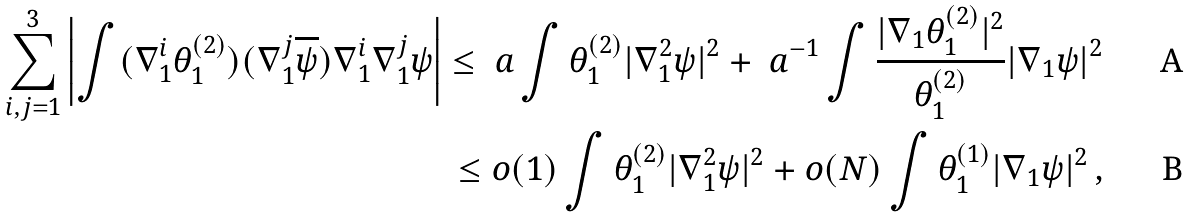<formula> <loc_0><loc_0><loc_500><loc_500>\sum _ { i , j = 1 } ^ { 3 } \left | \int ( \nabla _ { 1 } ^ { i } \theta _ { 1 } ^ { ( 2 ) } ) ( \nabla _ { 1 } ^ { j } \overline { \psi } ) \nabla _ { 1 } ^ { i } \nabla _ { 1 } ^ { j } \psi \right | \leq \ a \int \theta _ { 1 } ^ { ( 2 ) } | \nabla _ { 1 } ^ { 2 } \psi | ^ { 2 } + \ a ^ { - 1 } \int \frac { | \nabla _ { 1 } \theta _ { 1 } ^ { ( 2 ) } | ^ { 2 } } { \theta _ { 1 } ^ { ( 2 ) } } | \nabla _ { 1 } \psi | ^ { 2 } \\ \leq o ( 1 ) \int \theta _ { 1 } ^ { ( 2 ) } | \nabla _ { 1 } ^ { 2 } \psi | ^ { 2 } + o ( N ) \int \theta _ { 1 } ^ { ( 1 ) } | \nabla _ { 1 } \psi | ^ { 2 } \, ,</formula> 